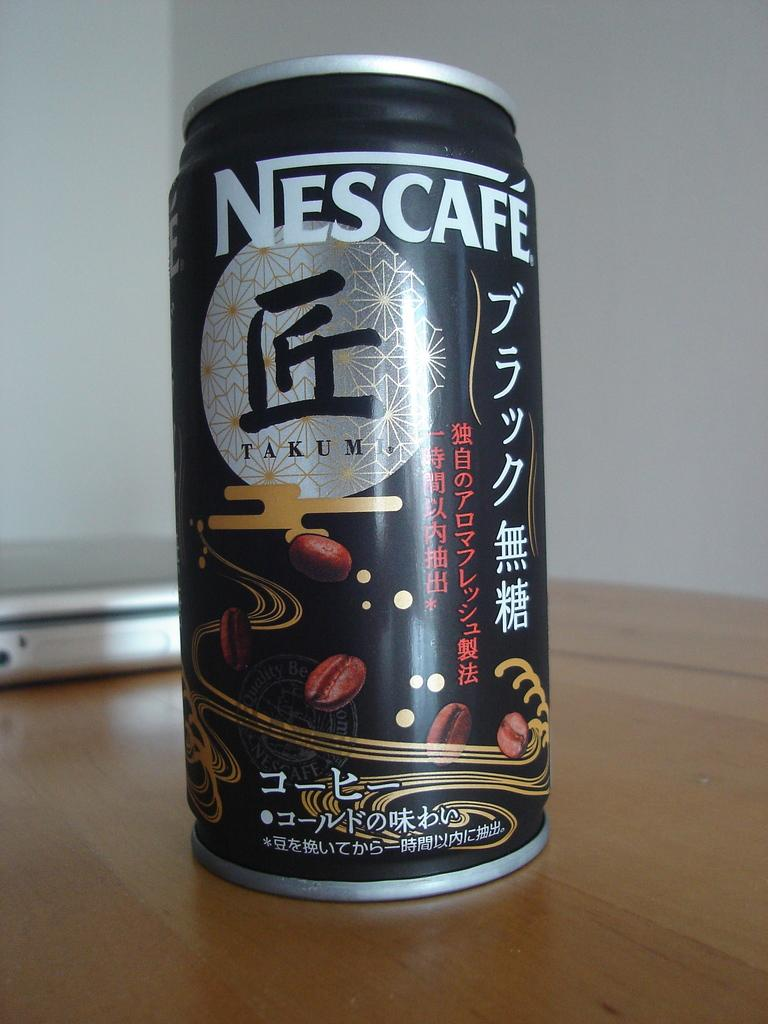Provide a one-sentence caption for the provided image. A can of Nescafe Takumi is sitting on a table. 